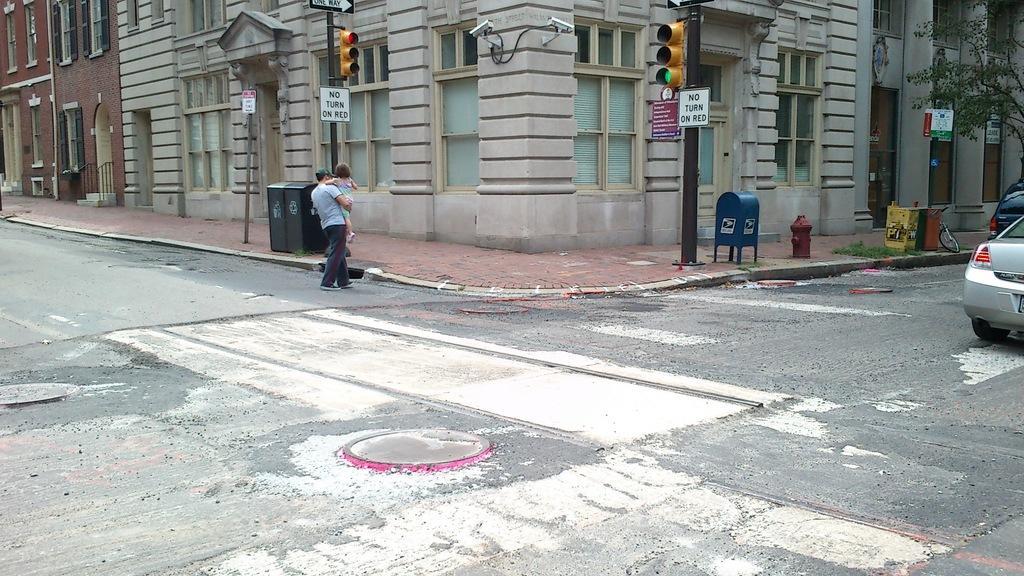Describe this image in one or two sentences. In this image we can see there is a building at the center of the image. Both the left and right side of the image there is a road. On the right side of the image there are some vehicles and trees on the road. Some signals are on the path of the road. 